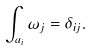Convert formula to latex. <formula><loc_0><loc_0><loc_500><loc_500>\int _ { a _ { i } } \omega _ { j } = \delta _ { i j } .</formula> 